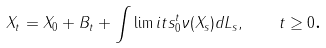Convert formula to latex. <formula><loc_0><loc_0><loc_500><loc_500>X _ { t } = X _ { 0 } + B _ { t } + \int \lim i t s _ { 0 } ^ { t } \nu ( X _ { s } ) d L _ { s } , \quad t \geq 0 \text {.}</formula> 